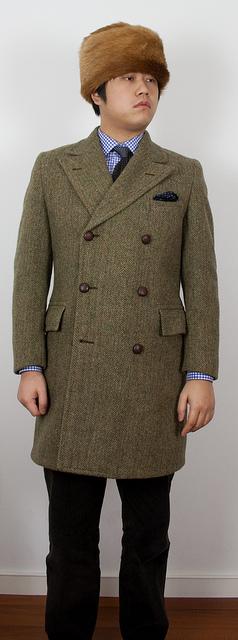Is the man wearing a fur hat?
Give a very brief answer. Yes. Is this man a Nubian king?
Keep it brief. No. Is he a statue?
Quick response, please. No. 